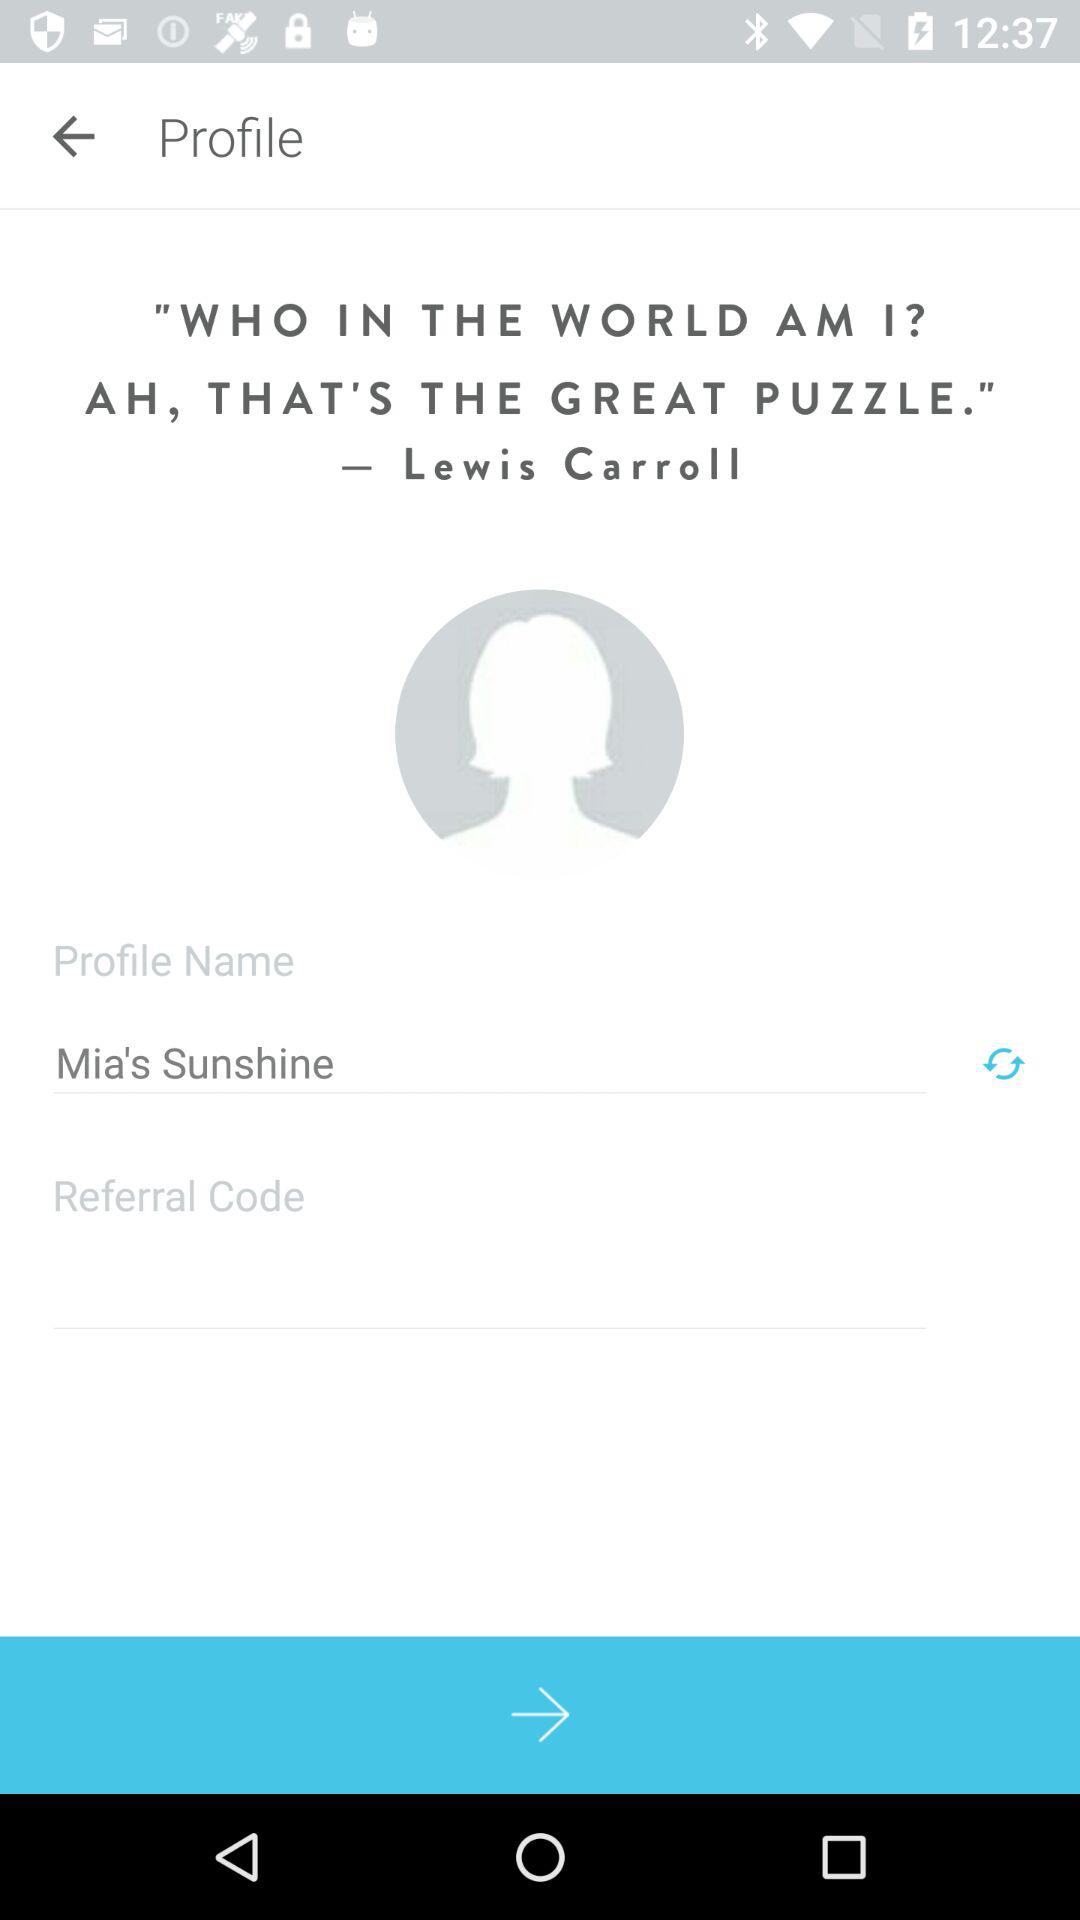What is the name of the profile? The name of the profile is "Mia's Sunshine". 